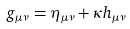<formula> <loc_0><loc_0><loc_500><loc_500>g _ { \mu \nu } = \eta _ { \mu \nu } + \kappa h _ { \mu \nu }</formula> 